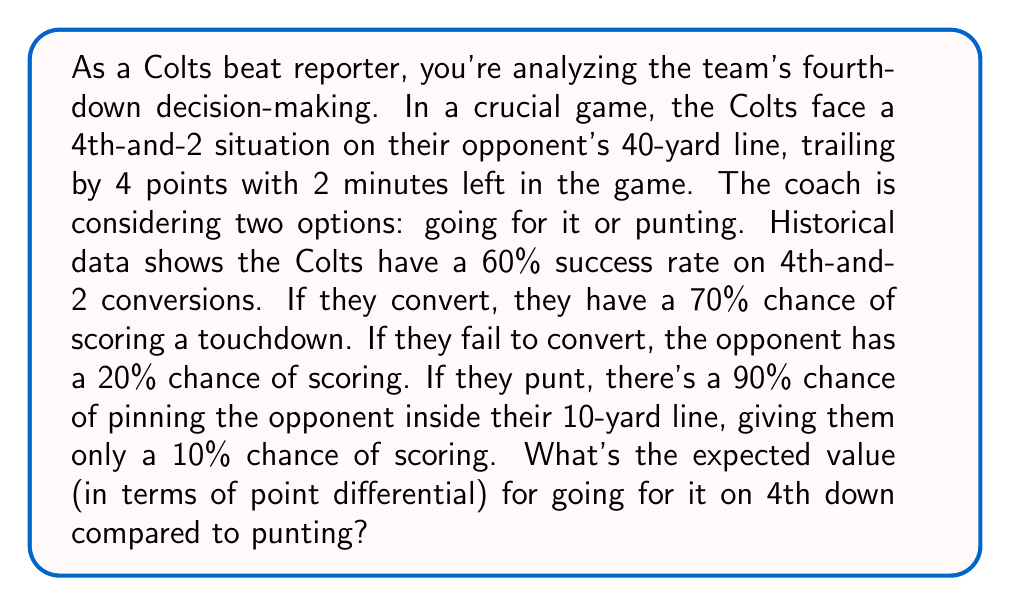Can you solve this math problem? Let's break this down step-by-step:

1. Define variables:
   $p_c$ = probability of converting (0.60)
   $p_t$ = probability of scoring a touchdown if converted (0.70)
   $p_f$ = probability of opponent scoring if failed conversion (0.20)
   $p_p$ = probability of pinning opponent inside 10-yard line if punted (0.90)
   $p_s$ = probability of opponent scoring if punted and pinned (0.10)

2. Calculate expected value of going for it:
   
   If they convert (60% chance):
   $$E(\text{convert}) = p_c \cdot (p_t \cdot 7 + (1-p_t) \cdot 0) = 0.60 \cdot (0.70 \cdot 7 + 0.30 \cdot 0) = 2.94$$

   If they fail to convert (40% chance):
   $$E(\text{fail}) = (1-p_c) \cdot (-p_f \cdot 7) = 0.40 \cdot (-0.20 \cdot 7) = -0.56$$

   Total expected value of going for it:
   $$E(\text{go}) = E(\text{convert}) + E(\text{fail}) = 2.94 + (-0.56) = 2.38$$

3. Calculate expected value of punting:
   
   If they pin the opponent (90% chance):
   $$E(\text{pin}) = p_p \cdot (-p_s \cdot 7) = 0.90 \cdot (-0.10 \cdot 7) = -0.63$$

   If they fail to pin (10% chance):
   $$E(\text{no pin}) = (1-p_p) \cdot (-0.20 \cdot 7) = 0.10 \cdot (-0.20 \cdot 7) = -0.14$$

   Total expected value of punting:
   $$E(\text{punt}) = E(\text{pin}) + E(\text{no pin}) = -0.63 + (-0.14) = -0.77$$

4. Compare the expected values:
   $$E(\text{go}) - E(\text{punt}) = 2.38 - (-0.77) = 3.15$$
Answer: The expected value of going for it on 4th down is 3.15 points higher than punting. 